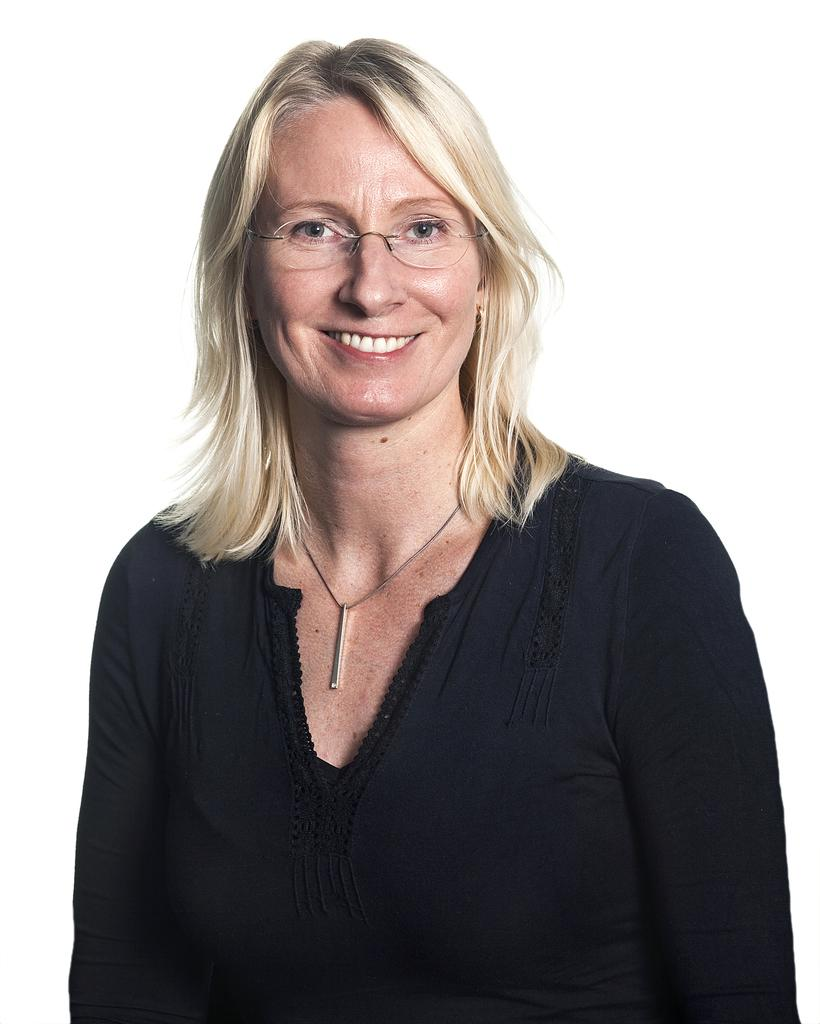Who is present in the image? There is a woman in the image. What is the woman's facial expression? The woman is smiling. What accessory is the woman wearing? The woman is wearing spectacles. What color is the background of the image? The background of the image is white. What type of bird is perched on the woman's hand in the image? There is no bird present in the image, nor is there any indication that the woman's hand is visible. 